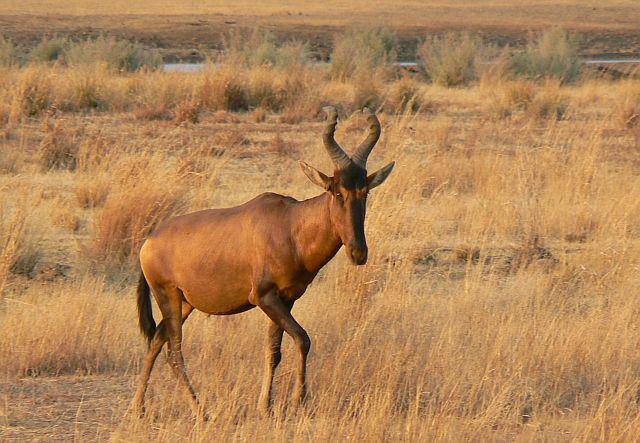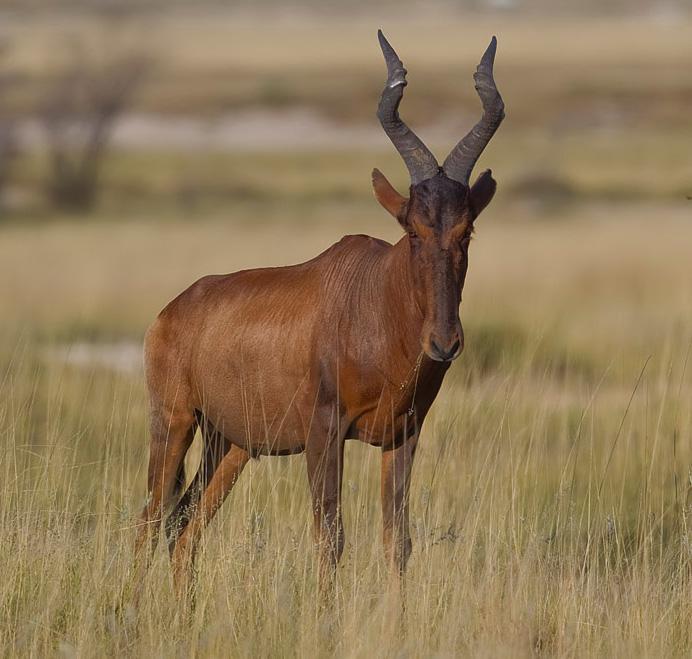The first image is the image on the left, the second image is the image on the right. Examine the images to the left and right. Is the description "Two brown horned animals positioned sideways toward the same direction are alone in a wilderness area, at least one of them showing its tail." accurate? Answer yes or no. Yes. The first image is the image on the left, the second image is the image on the right. Given the left and right images, does the statement "Two antelopes are facing right." hold true? Answer yes or no. Yes. 